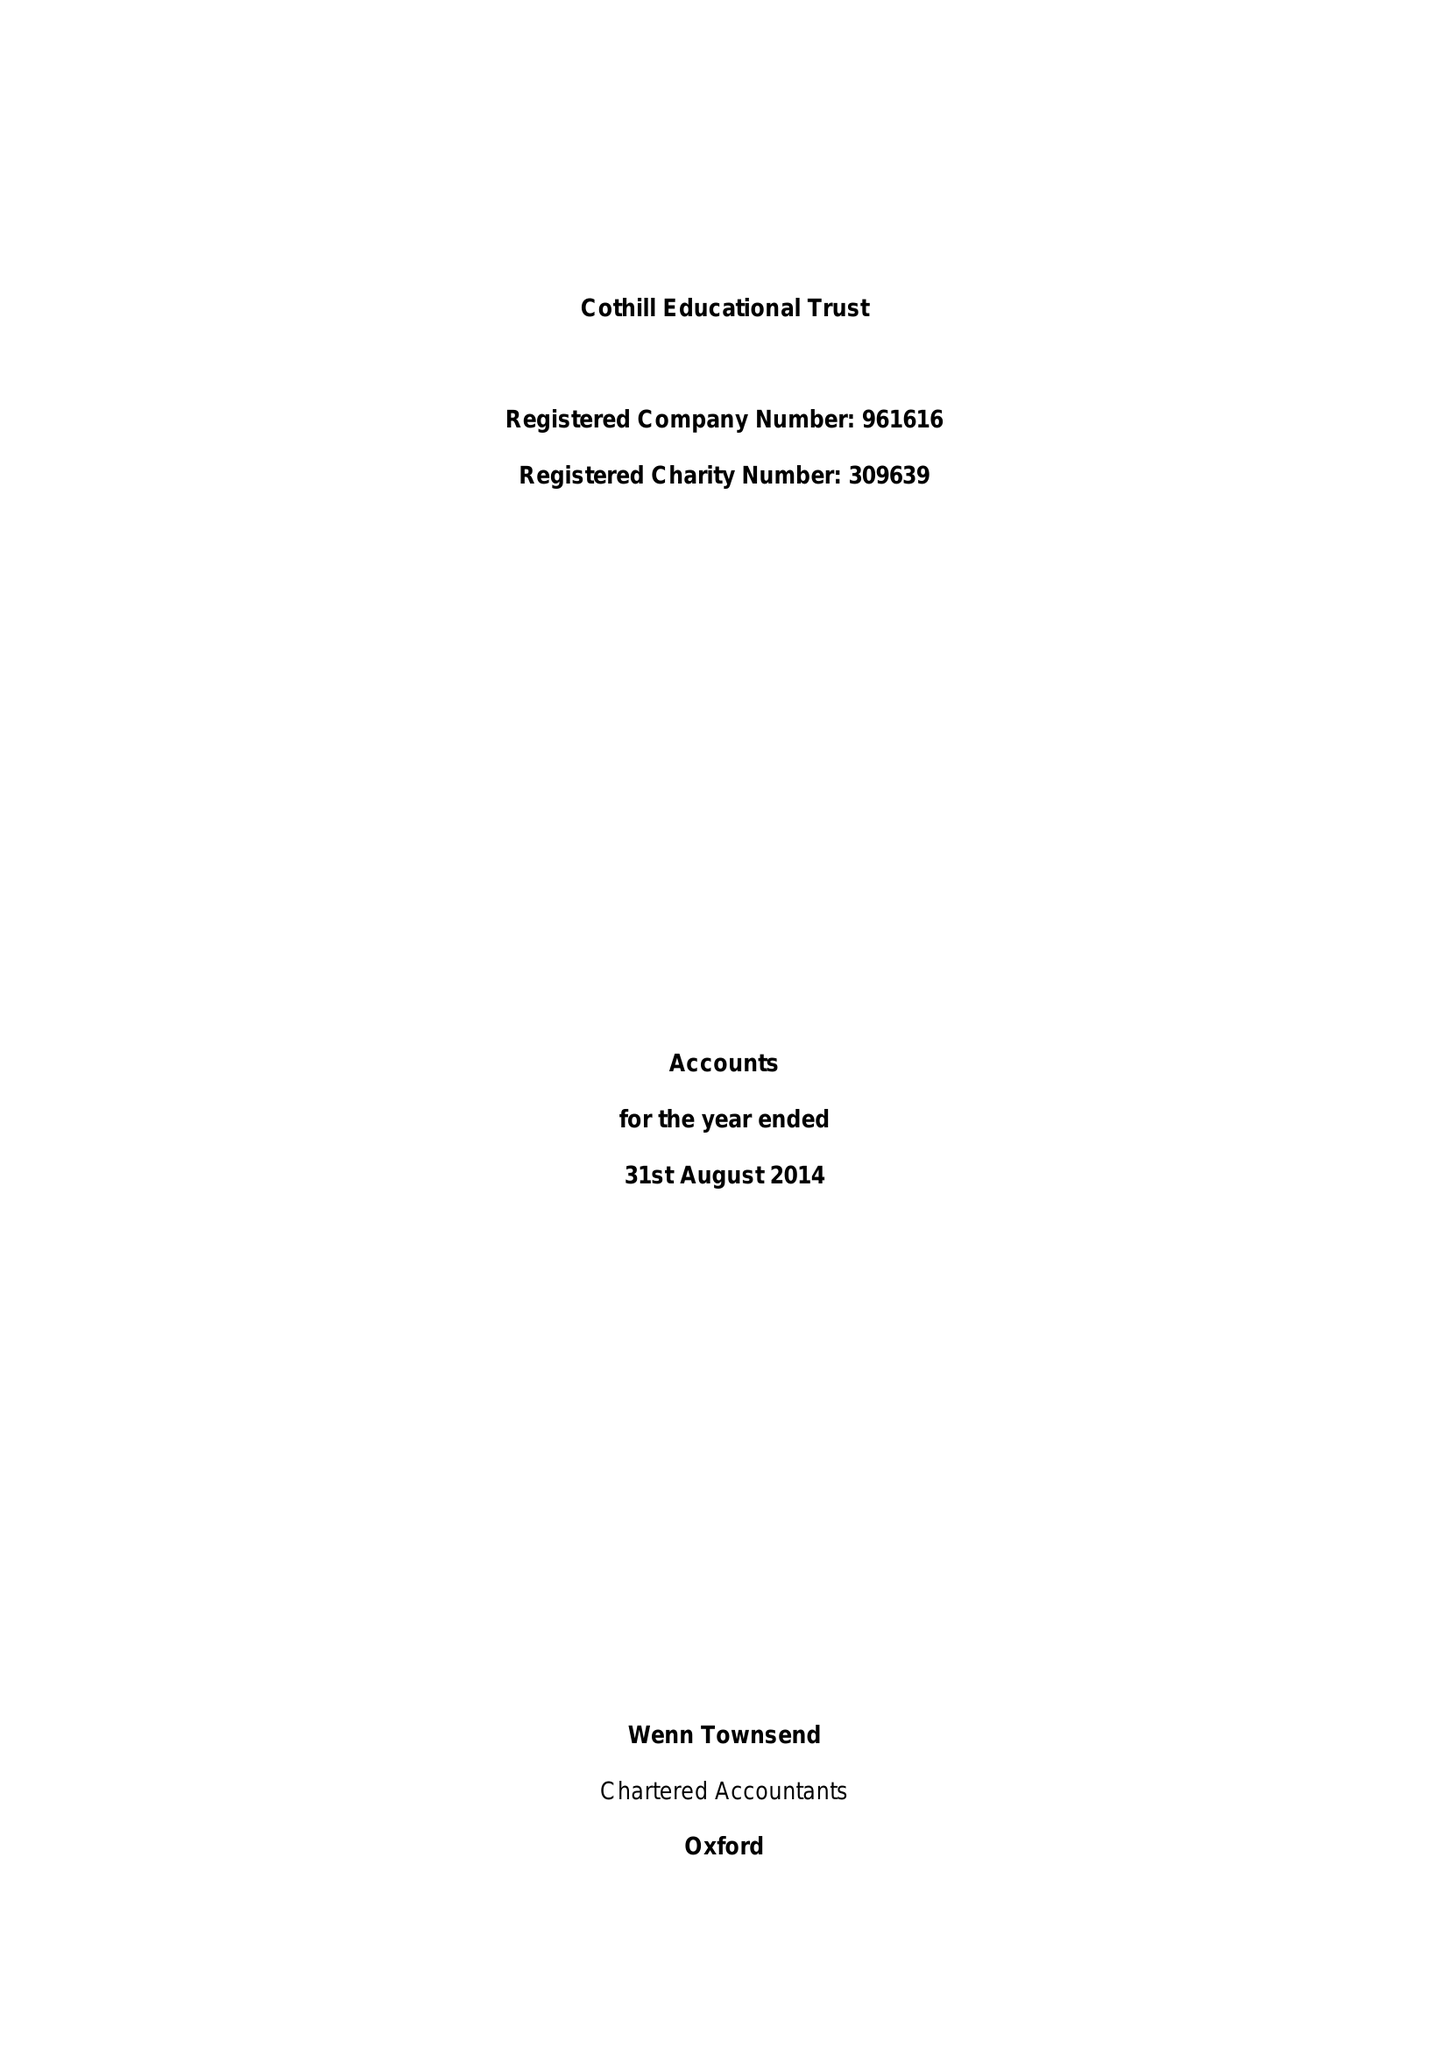What is the value for the report_date?
Answer the question using a single word or phrase. 2014-08-31 